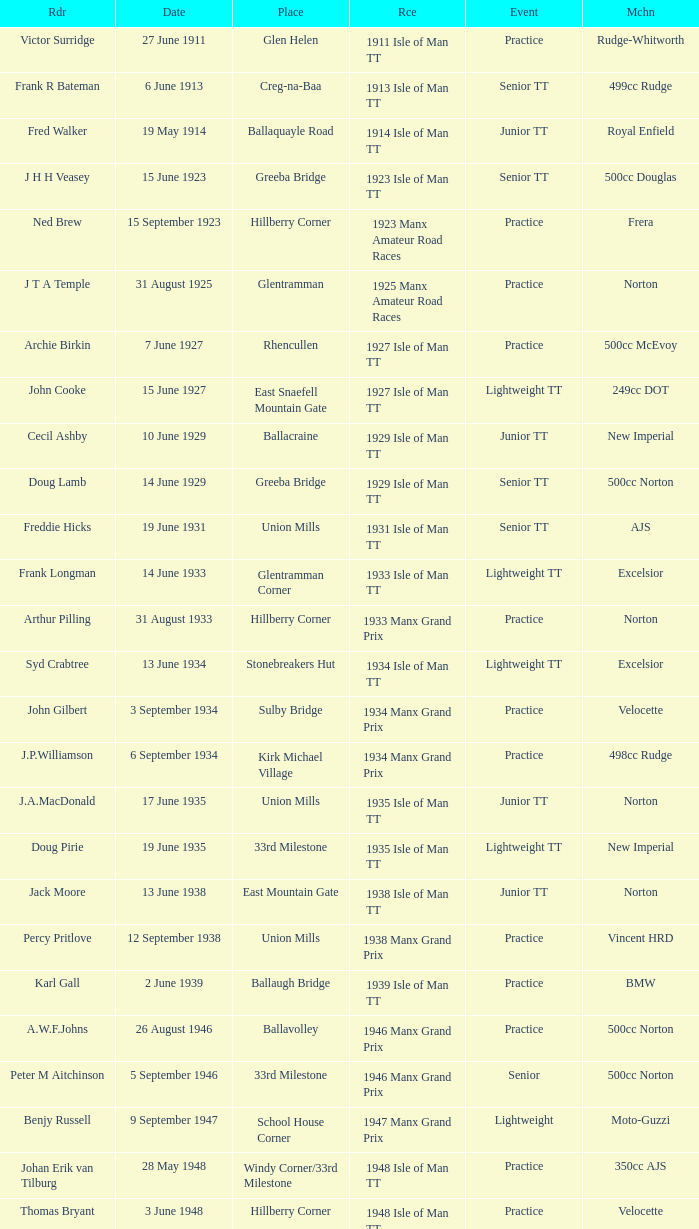Where was the 249cc Yamaha? Glentramman. 